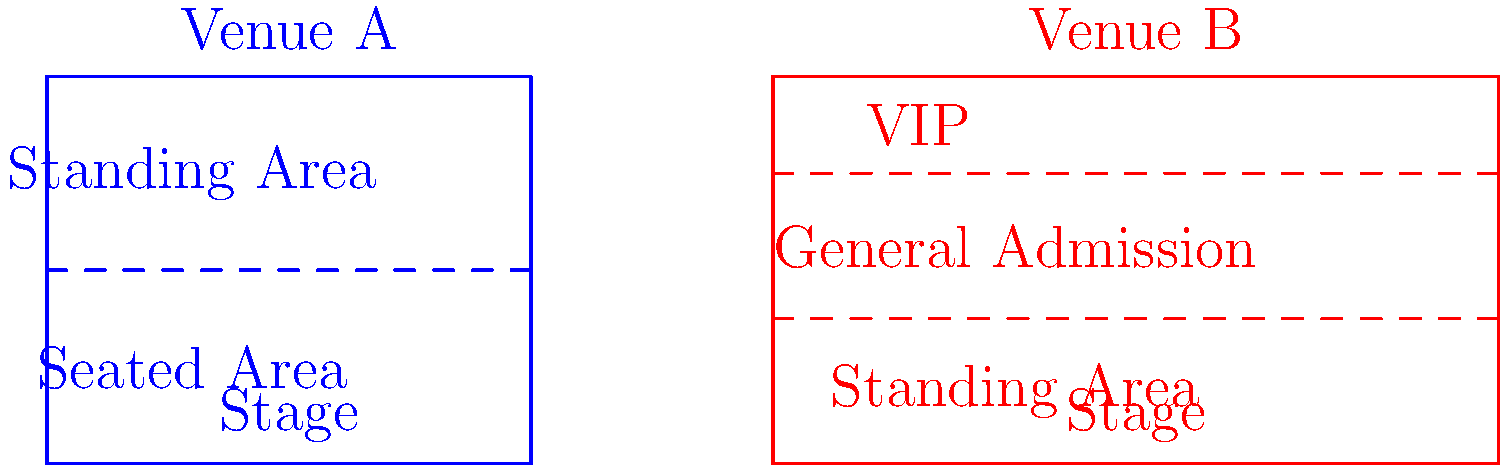As a music enthusiast, you're comparing two concert venues for upcoming shows. Venue A has a total capacity of 2000 people, with the standing area accommodating twice as many people as the seated area. Venue B has a total capacity of 2400 people, with the VIP section holding 200 people, and the general admission area holding twice as many people as the standing area. Based on the floor plans provided, what is the difference in capacity between the general admission area of Venue B and the standing area of Venue A? Let's approach this step-by-step:

1. For Venue A:
   - Total capacity = 2000
   - Let x be the number of people in the seated area
   - Then, 2x is the number of people in the standing area
   - We can write the equation: x + 2x = 2000
   - Solving this: 3x = 2000, so x = 2000/3 ≈ 667 (rounded)
   - Standing area capacity in Venue A = 2x ≈ 1333

2. For Venue B:
   - Total capacity = 2400
   - VIP section capacity = 200
   - Let y be the number of people in the standing area
   - Then, 2y is the number of people in the general admission area
   - We can write the equation: 200 + 2y + y = 2400
   - Simplifying: 200 + 3y = 2400
   - Solving this: 3y = 2200, so y ≈ 733 (rounded)
   - General admission area capacity in Venue B = 2y ≈ 1466

3. Calculate the difference:
   General admission area (Venue B) - Standing area (Venue A)
   = 1466 - 1333 = 133

Therefore, the difference in capacity between the general admission area of Venue B and the standing area of Venue A is approximately 133 people.
Answer: 133 people 